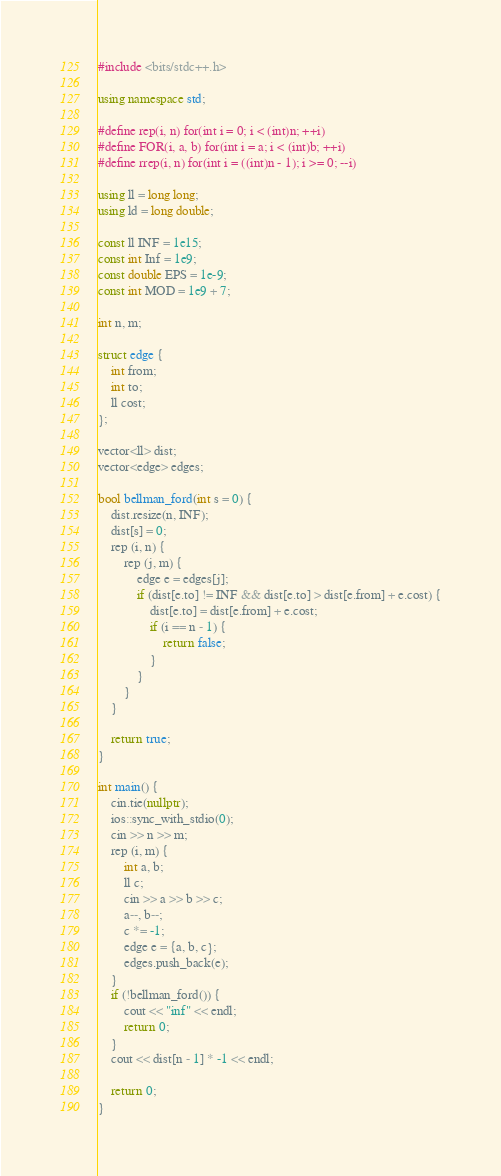<code> <loc_0><loc_0><loc_500><loc_500><_C++_>#include <bits/stdc++.h>

using namespace std;

#define rep(i, n) for(int i = 0; i < (int)n; ++i)
#define FOR(i, a, b) for(int i = a; i < (int)b; ++i)
#define rrep(i, n) for(int i = ((int)n - 1); i >= 0; --i)

using ll = long long;
using ld = long double;

const ll INF = 1e15;
const int Inf = 1e9;
const double EPS = 1e-9;
const int MOD = 1e9 + 7;

int n, m;

struct edge {
    int from;
    int to;
    ll cost;
};

vector<ll> dist;
vector<edge> edges;

bool bellman_ford(int s = 0) {
    dist.resize(n, INF);
    dist[s] = 0;
    rep (i, n) {
        rep (j, m) {
            edge e = edges[j];
            if (dist[e.to] != INF && dist[e.to] > dist[e.from] + e.cost) {
                dist[e.to] = dist[e.from] + e.cost;
                if (i == n - 1) {
                    return false;
                }
            }
        }
    }

    return true;
}

int main() {
    cin.tie(nullptr);
    ios::sync_with_stdio(0);
    cin >> n >> m;
    rep (i, m) {
        int a, b;
        ll c;
        cin >> a >> b >> c;
        a--, b--;
        c *= -1;
        edge e = {a, b, c};
        edges.push_back(e);
    }
    if (!bellman_ford()) {
        cout << "inf" << endl;
        return 0;
    }
    cout << dist[n - 1] * -1 << endl;
    
    return 0;
}

</code> 